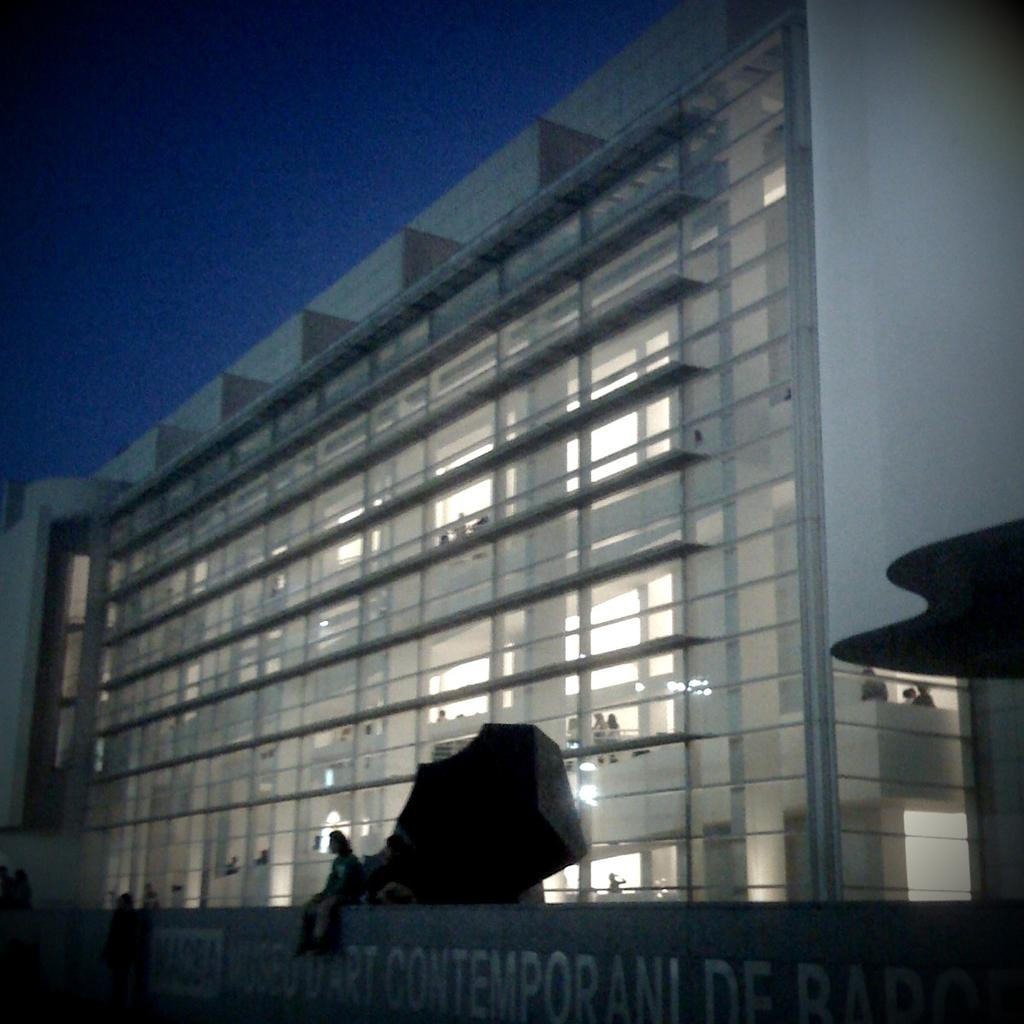What is happening inside the building in the image? There are people inside the building. What is happening on the wall in the image? There are people on the wall. What can be read on the wall in the image? There is text on the wall. What is visible in the background of the image? The sky is visible in the image. What type of government is depicted on the wall in the image? There is no depiction of a government on the wall in the image; it features people and text. Is the queen present in the image? There is no queen present in the image; it features people inside the building and on the wall, as well as text and the sky. 